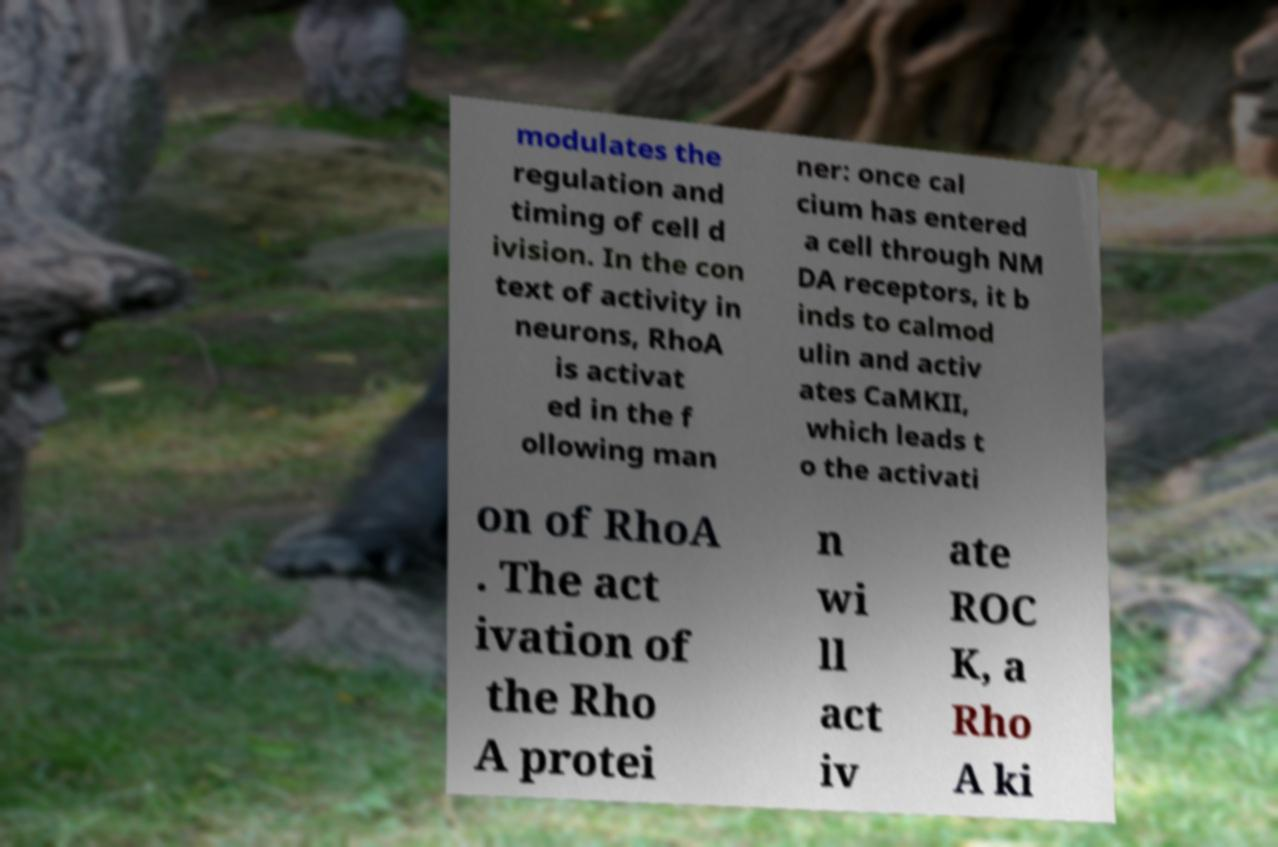Can you accurately transcribe the text from the provided image for me? modulates the regulation and timing of cell d ivision. In the con text of activity in neurons, RhoA is activat ed in the f ollowing man ner: once cal cium has entered a cell through NM DA receptors, it b inds to calmod ulin and activ ates CaMKII, which leads t o the activati on of RhoA . The act ivation of the Rho A protei n wi ll act iv ate ROC K, a Rho A ki 